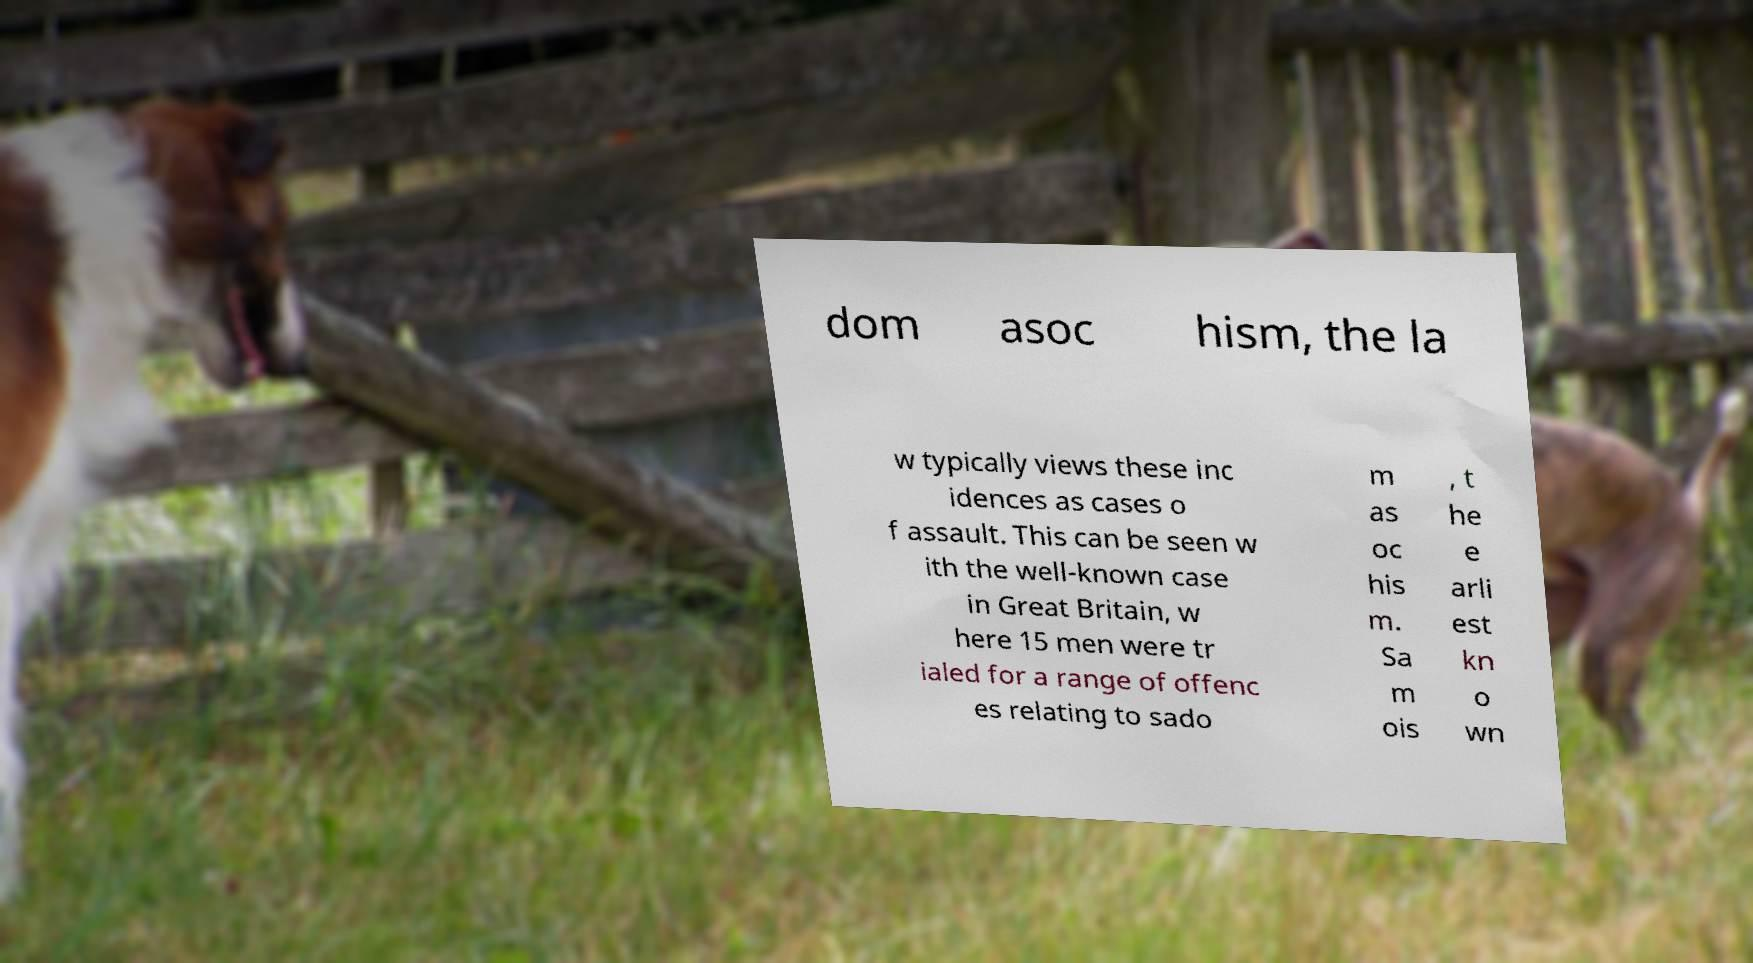There's text embedded in this image that I need extracted. Can you transcribe it verbatim? dom asoc hism, the la w typically views these inc idences as cases o f assault. This can be seen w ith the well-known case in Great Britain, w here 15 men were tr ialed for a range of offenc es relating to sado m as oc his m. Sa m ois , t he e arli est kn o wn 